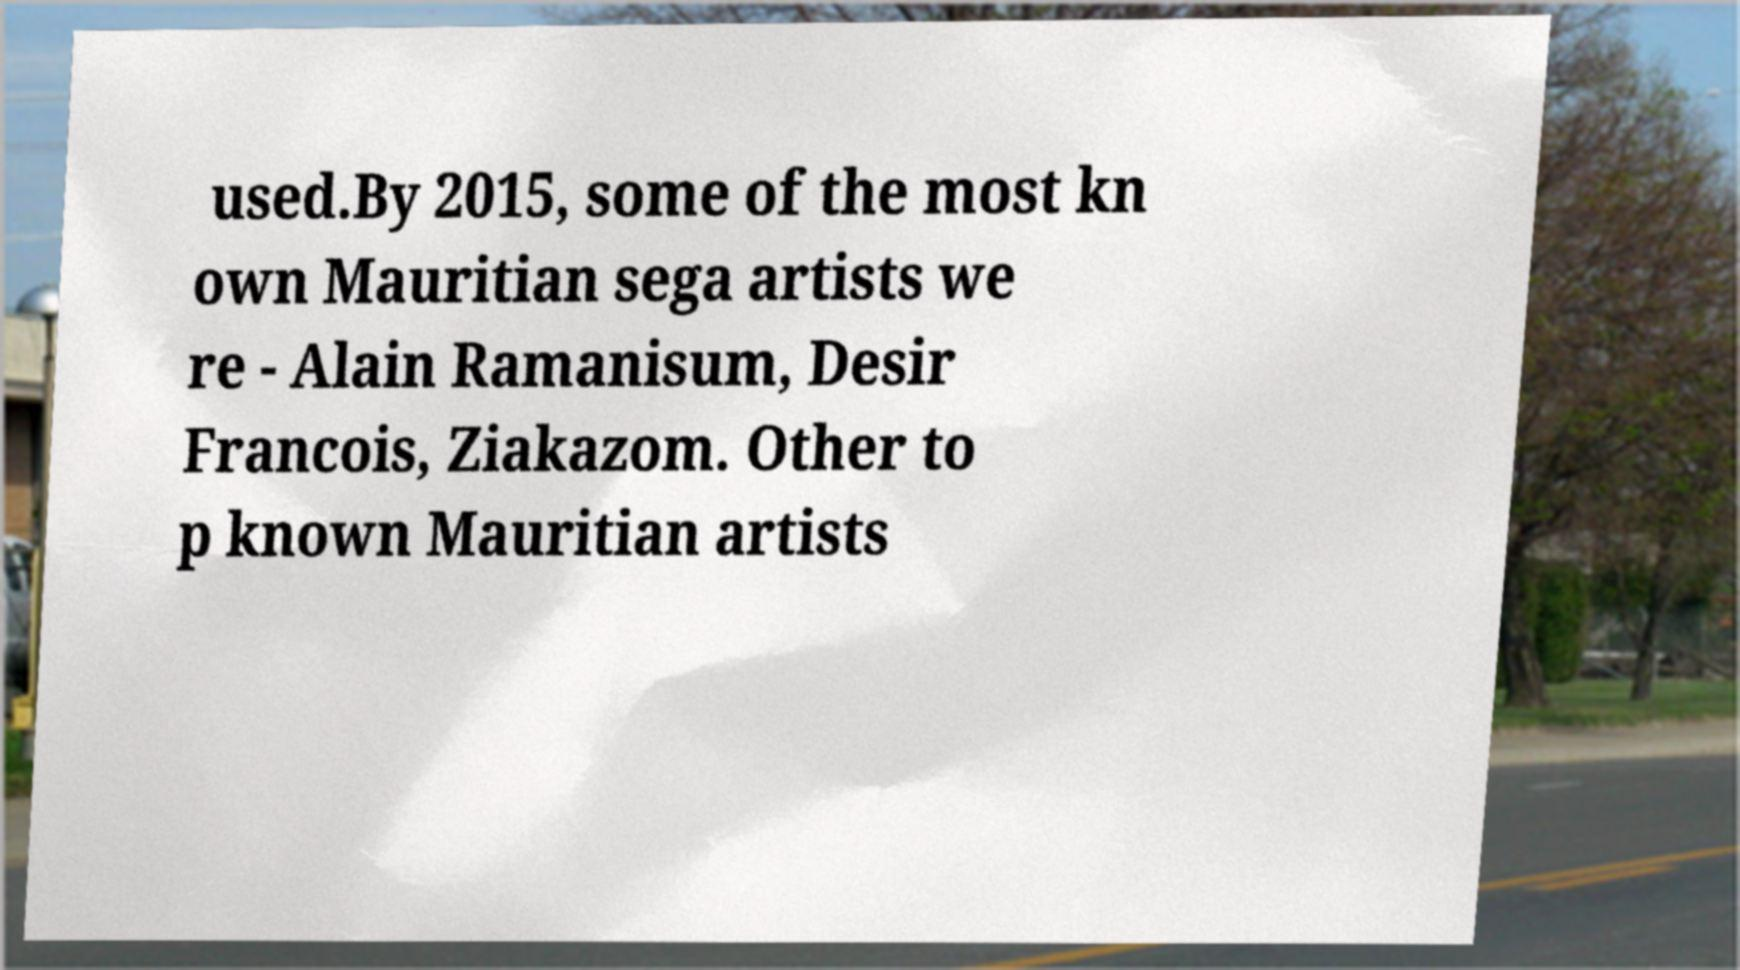Could you assist in decoding the text presented in this image and type it out clearly? used.By 2015, some of the most kn own Mauritian sega artists we re - Alain Ramanisum, Desir Francois, Ziakazom. Other to p known Mauritian artists 